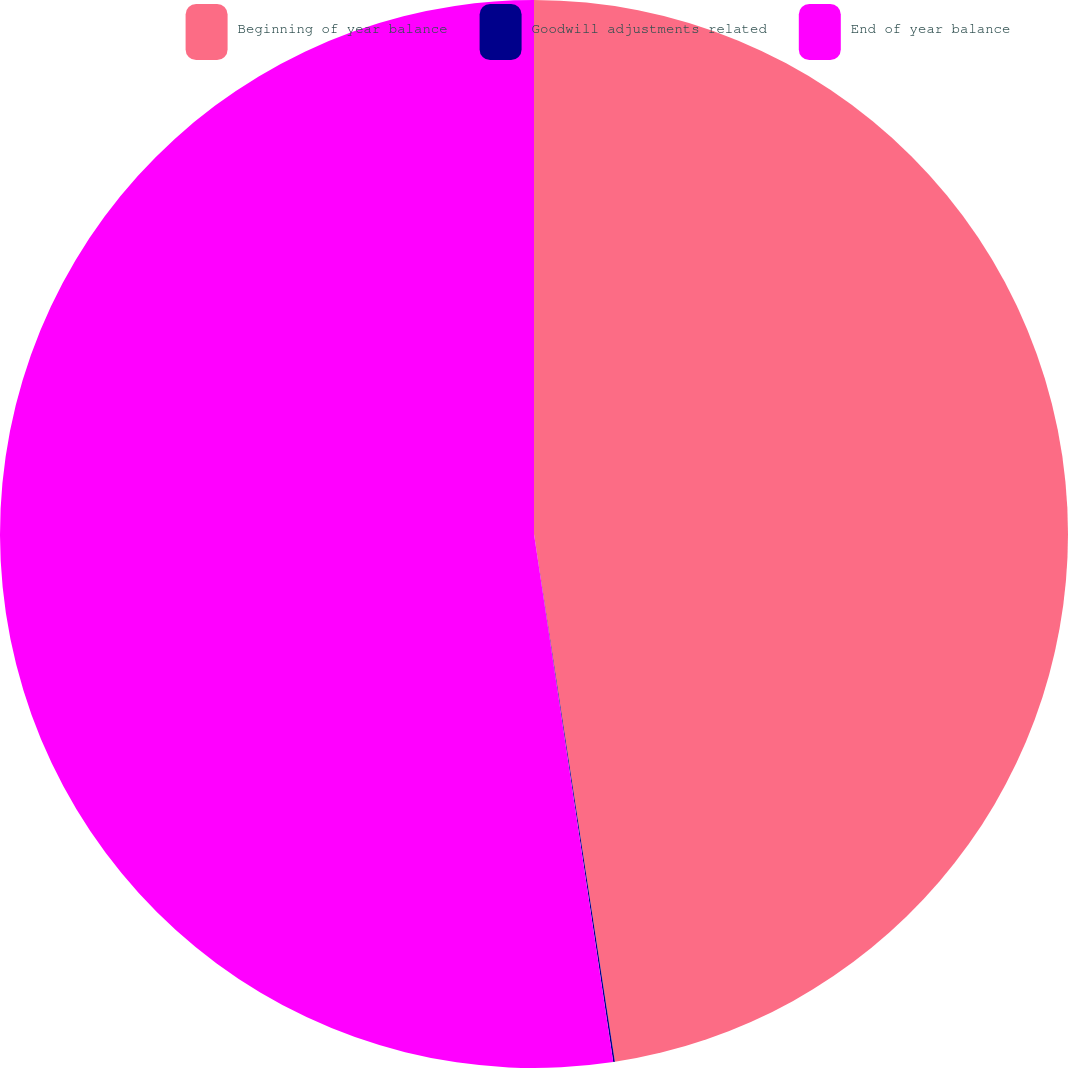<chart> <loc_0><loc_0><loc_500><loc_500><pie_chart><fcel>Beginning of year balance<fcel>Goodwill adjustments related<fcel>End of year balance<nl><fcel>47.58%<fcel>0.05%<fcel>52.37%<nl></chart> 